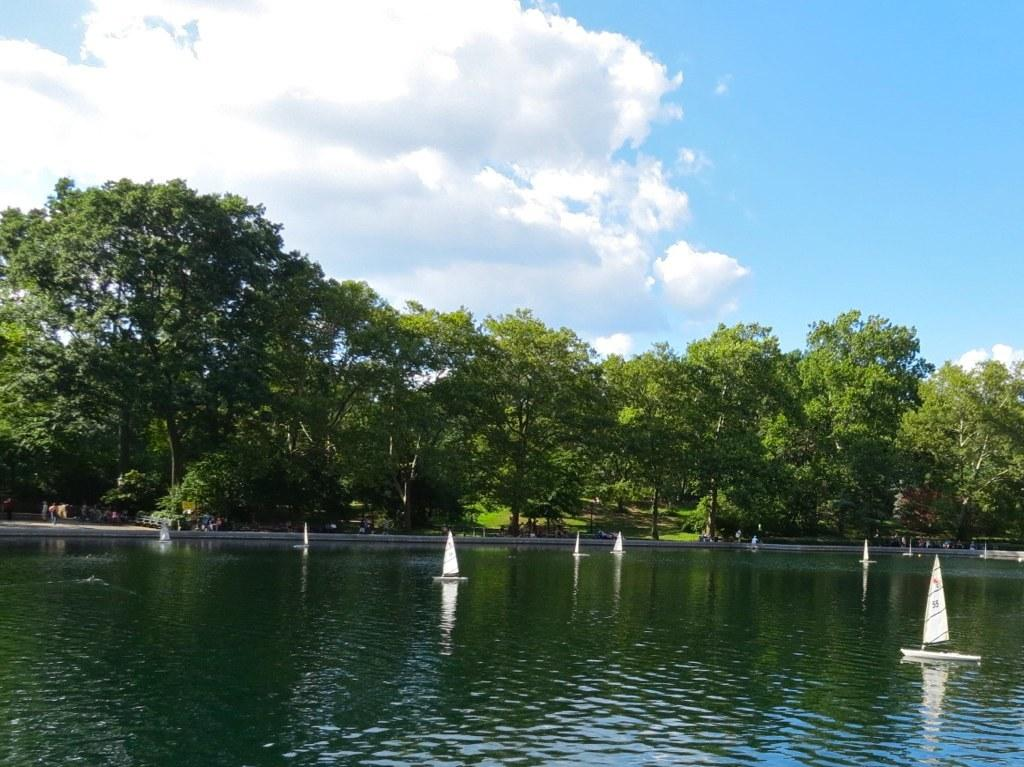What is in the water in the image? There are boats in the water in the image. What can be seen in the background of the image? There are trees and the sky visible in the background of the image. How many friends are sitting on the nail in the image? There is no nail or friends present in the image. What type of cars can be seen driving through the water in the image? There are no cars visible in the image; it features boats in the water. 